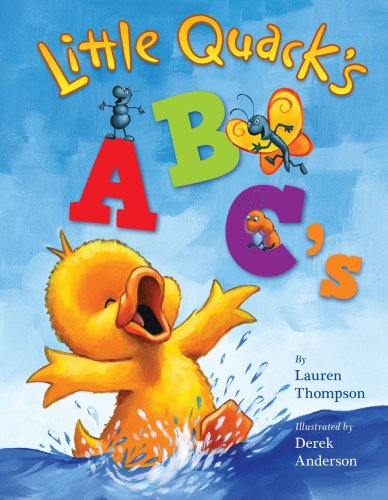Who is the author of this book?
Answer the question using a single word or phrase. Lauren Thompson What is the title of this book? Little Quack's ABC's (Super Chubbies) What is the genre of this book? Children's Books Is this a kids book? Yes Is this a journey related book? No 